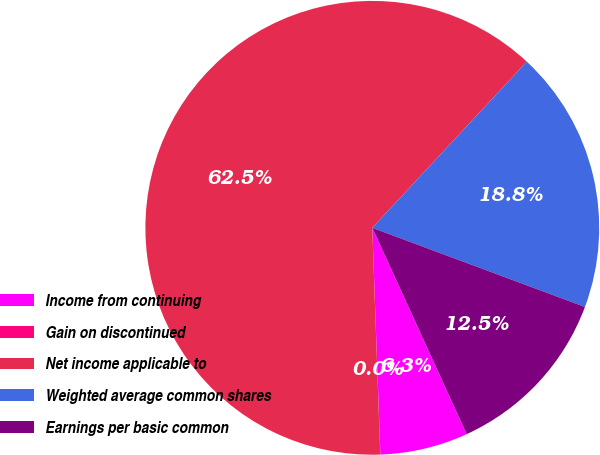<chart> <loc_0><loc_0><loc_500><loc_500><pie_chart><fcel>Income from continuing<fcel>Gain on discontinued<fcel>Net income applicable to<fcel>Weighted average common shares<fcel>Earnings per basic common<nl><fcel>6.26%<fcel>0.01%<fcel>62.48%<fcel>18.75%<fcel>12.5%<nl></chart> 